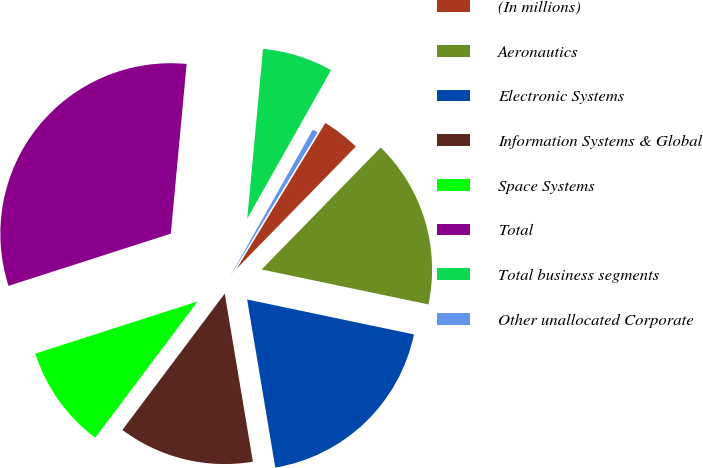<chart> <loc_0><loc_0><loc_500><loc_500><pie_chart><fcel>(In millions)<fcel>Aeronautics<fcel>Electronic Systems<fcel>Information Systems & Global<fcel>Space Systems<fcel>Total<fcel>Total business segments<fcel>Other unallocated Corporate<nl><fcel>3.61%<fcel>15.98%<fcel>19.07%<fcel>12.89%<fcel>9.8%<fcel>31.43%<fcel>6.7%<fcel>0.52%<nl></chart> 